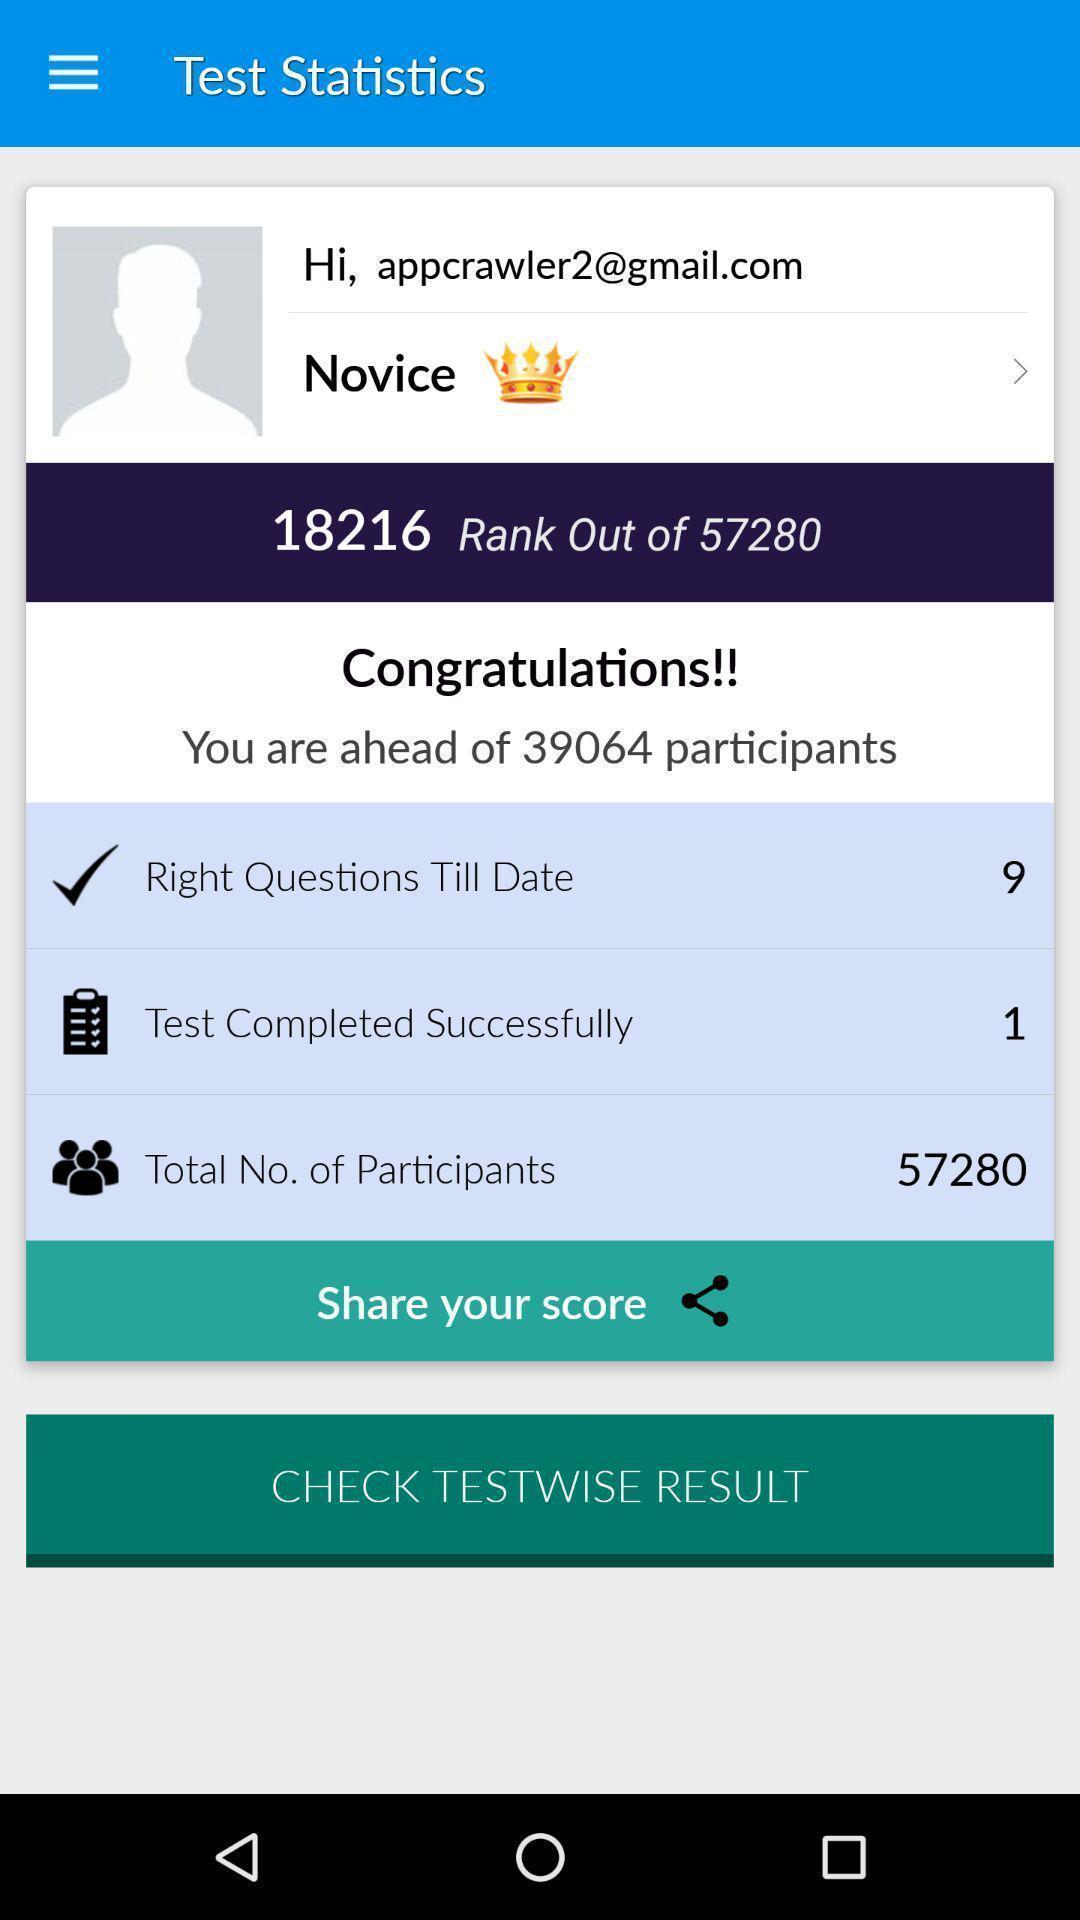Summarize the information in this screenshot. Page displaying test statistics in a learning app. 